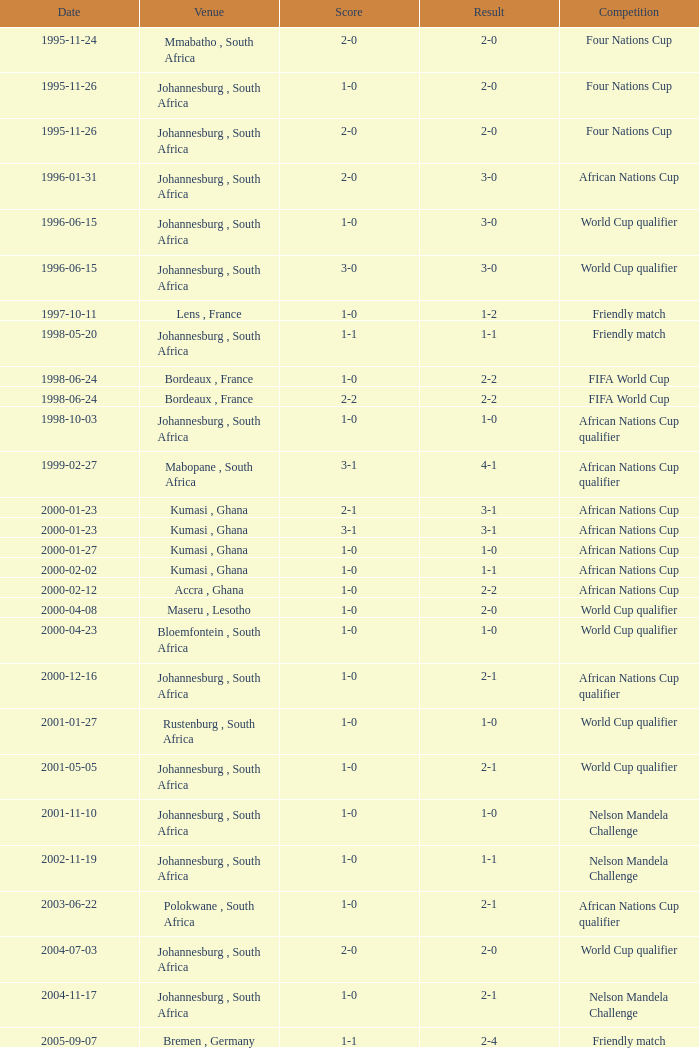What is the site of the championship on 2001-05-05? Johannesburg , South Africa. 